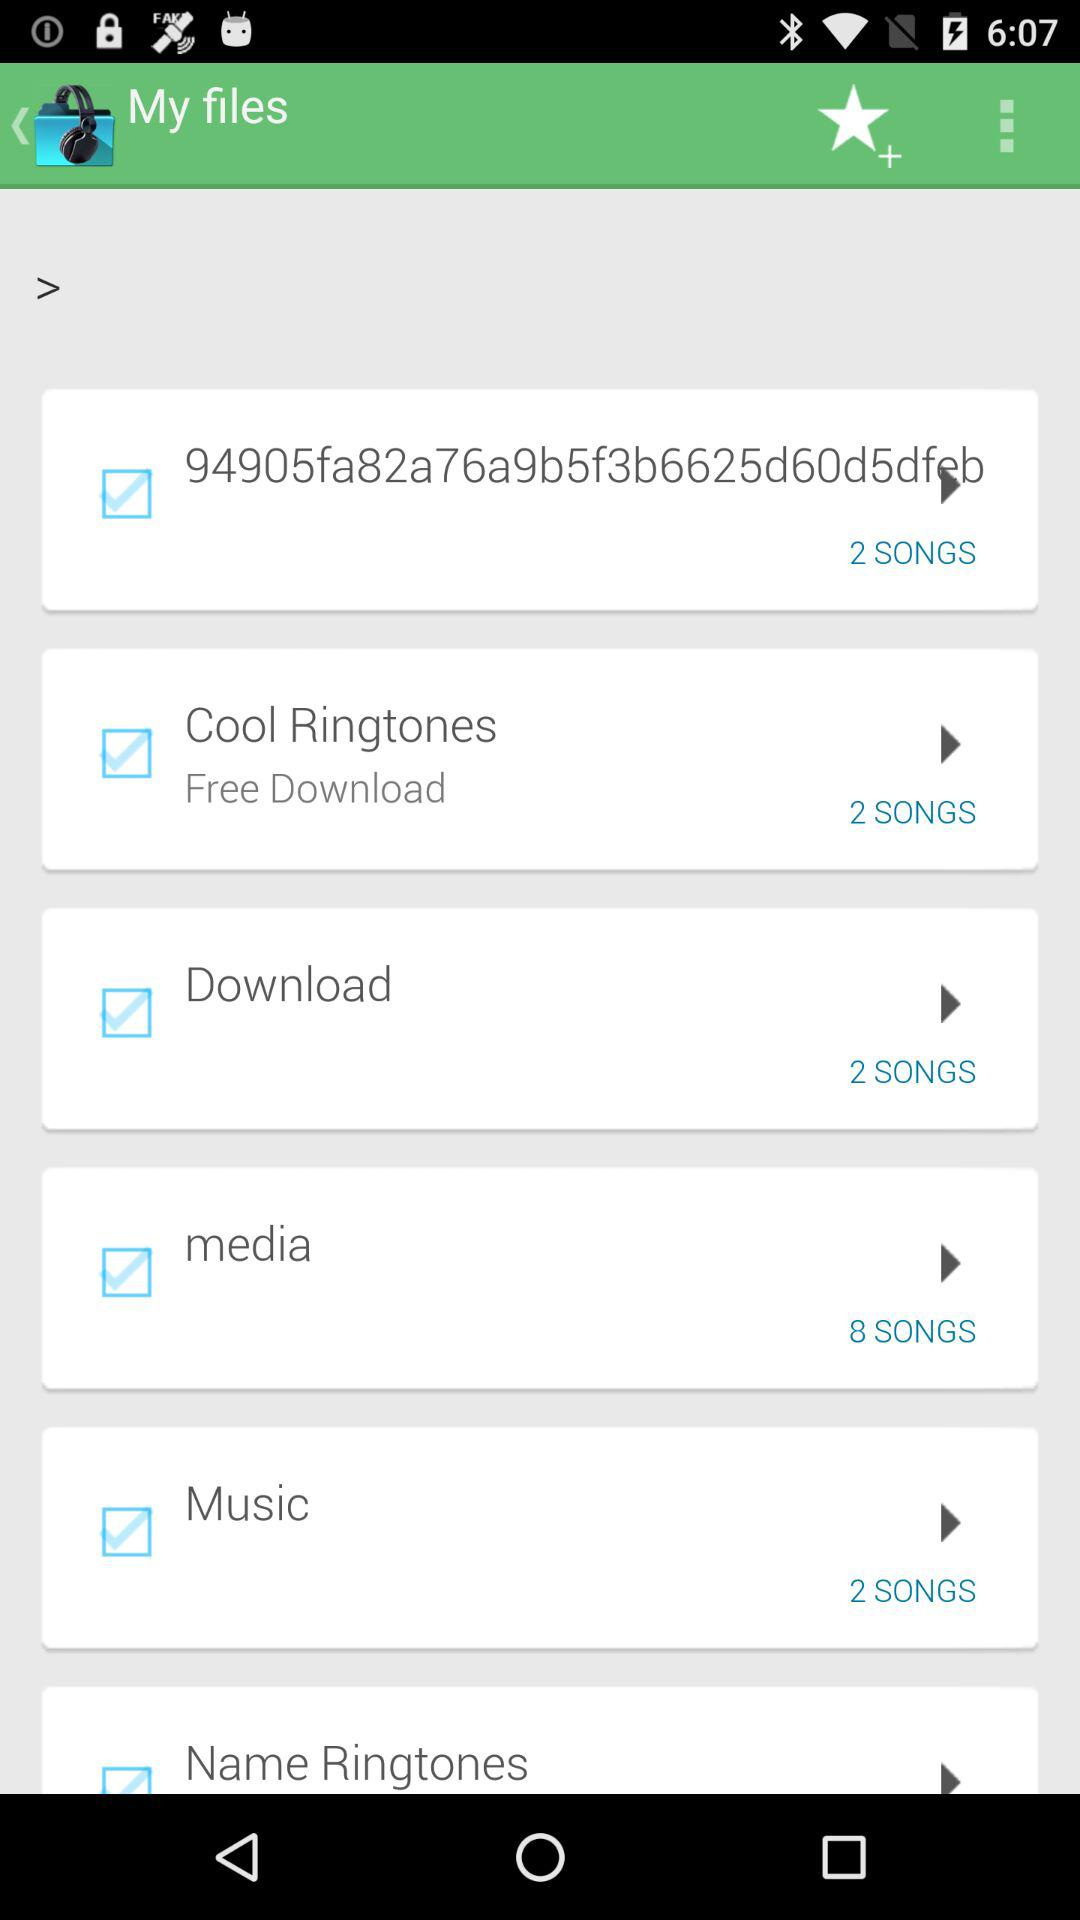How many songs are there in the "Cool Ringtones" folder? There are 2 songs in the "Cool Ringtones" folder. 